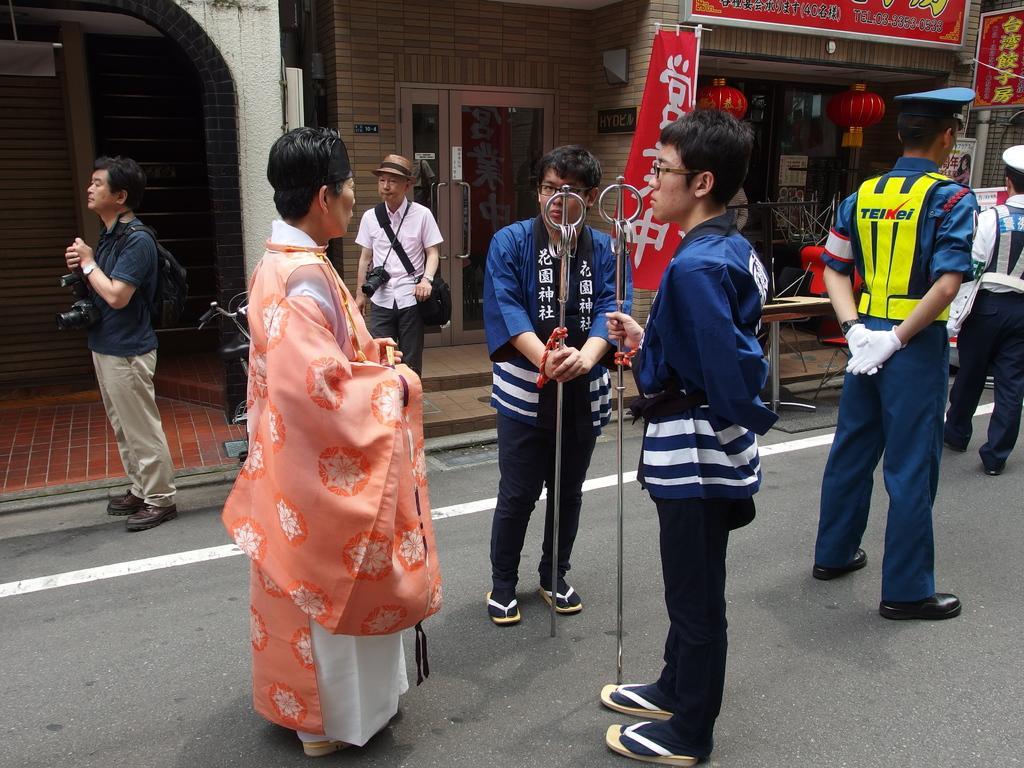How would you summarize this image in a sentence or two? Here in this picture we can see a group of people standing on the road and the person on the left side is wearing a royal dress and in front of him we can see two men standing and holding something in their hands and both of them are wearing spectacles and in front of them we can see some people standing in a uniform with gloves and cap on them and beside them we can see some people carrying cameras and bags with them present over there and we can also see stored present beside them and we can also see door present and we can see one person is wearing hat on him. 